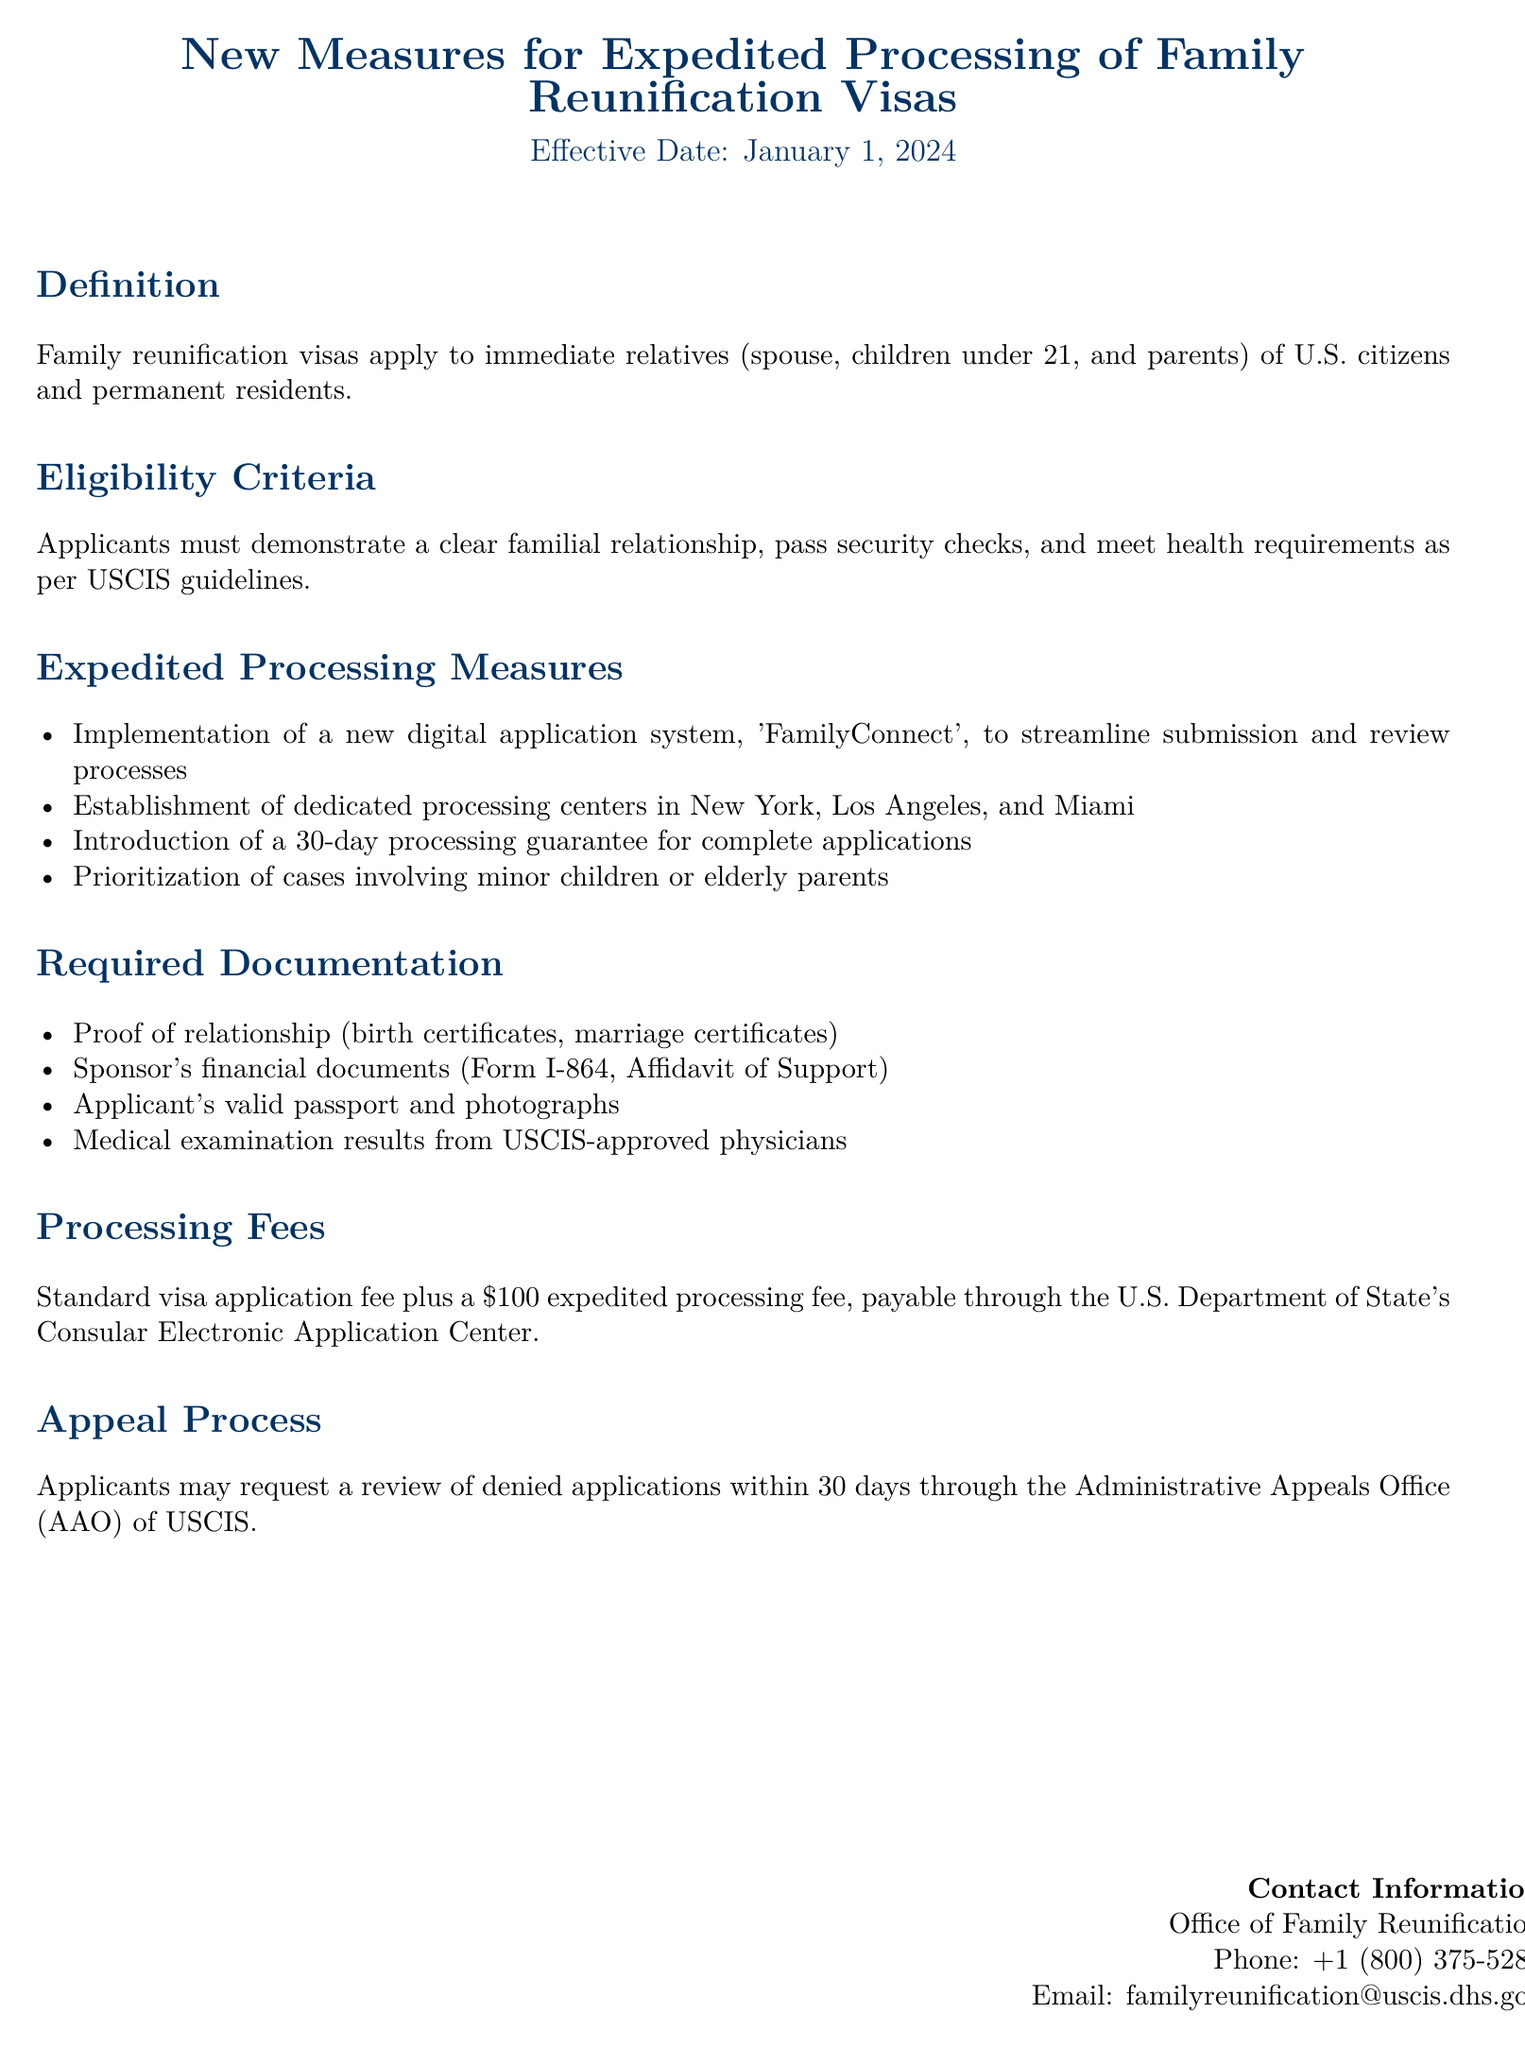What is the effective date of the new measures? The document states that the measures are effective starting January 1, 2024.
Answer: January 1, 2024 Who qualifies for family reunification visas? The document defines eligible applicants as immediate relatives of U.S. citizens and permanent residents, which includes spouses, children under 21, and parents.
Answer: Immediate relatives: spouse, children under 21, parents What is the processing guarantee time frame for complete applications? The document mentions a 30-day processing guarantee for complete applications.
Answer: 30 days Which system is implemented to streamline the process? The document introduces a new digital application system named 'FamilyConnect' to handle submissions and reviews.
Answer: FamilyConnect Where are the dedicated processing centers located? The document lists New York, Los Angeles, and Miami as the locations for the dedicated processing centers.
Answer: New York, Los Angeles, Miami What additional fee is associated with expedited processing? The document specifies a $100 expedited processing fee on top of the standard application fee.
Answer: $100 What are the required documents to prove relationship? The document lists birth certificates and marriage certificates as proof of relationship.
Answer: Birth certificates, marriage certificates What is the appeal process for denied applications? The document states that applicants may request a review of denied applications within 30 days through the Administrative Appeals Office (AAO) of USCIS.
Answer: 30 days through AAO 